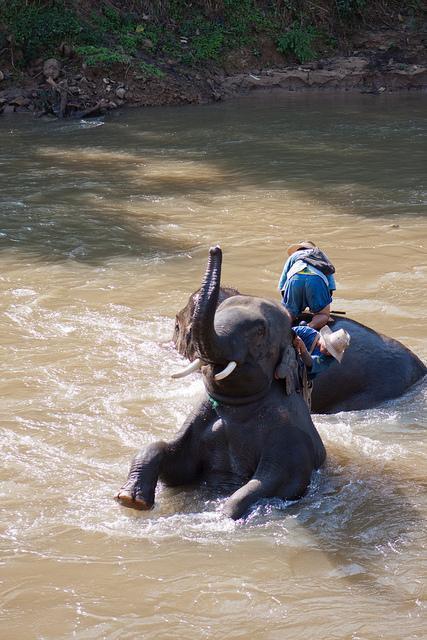How many elephants are visible?
Give a very brief answer. 2. How many people are there?
Give a very brief answer. 2. 